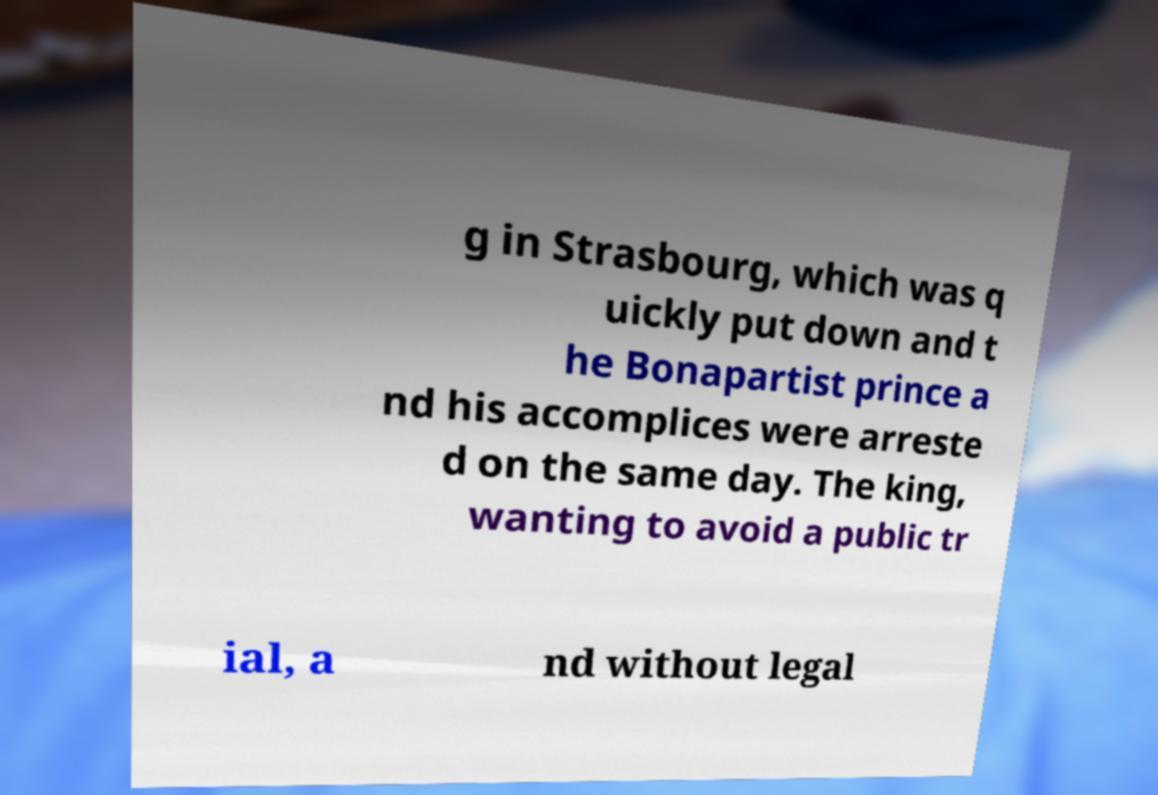Could you extract and type out the text from this image? g in Strasbourg, which was q uickly put down and t he Bonapartist prince a nd his accomplices were arreste d on the same day. The king, wanting to avoid a public tr ial, a nd without legal 